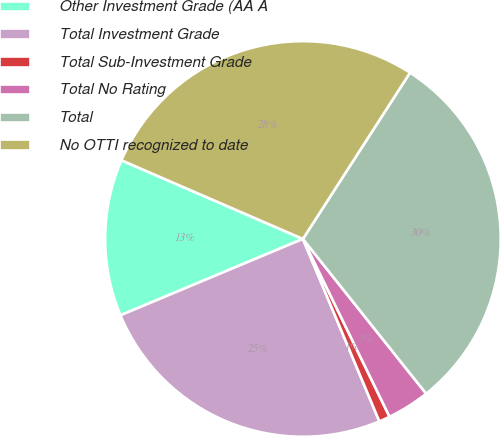Convert chart to OTSL. <chart><loc_0><loc_0><loc_500><loc_500><pie_chart><fcel>Other Investment Grade (AA A<fcel>Total Investment Grade<fcel>Total Sub-Investment Grade<fcel>Total No Rating<fcel>Total<fcel>No OTTI recognized to date<nl><fcel>12.82%<fcel>25.01%<fcel>0.9%<fcel>3.49%<fcel>30.19%<fcel>27.6%<nl></chart> 